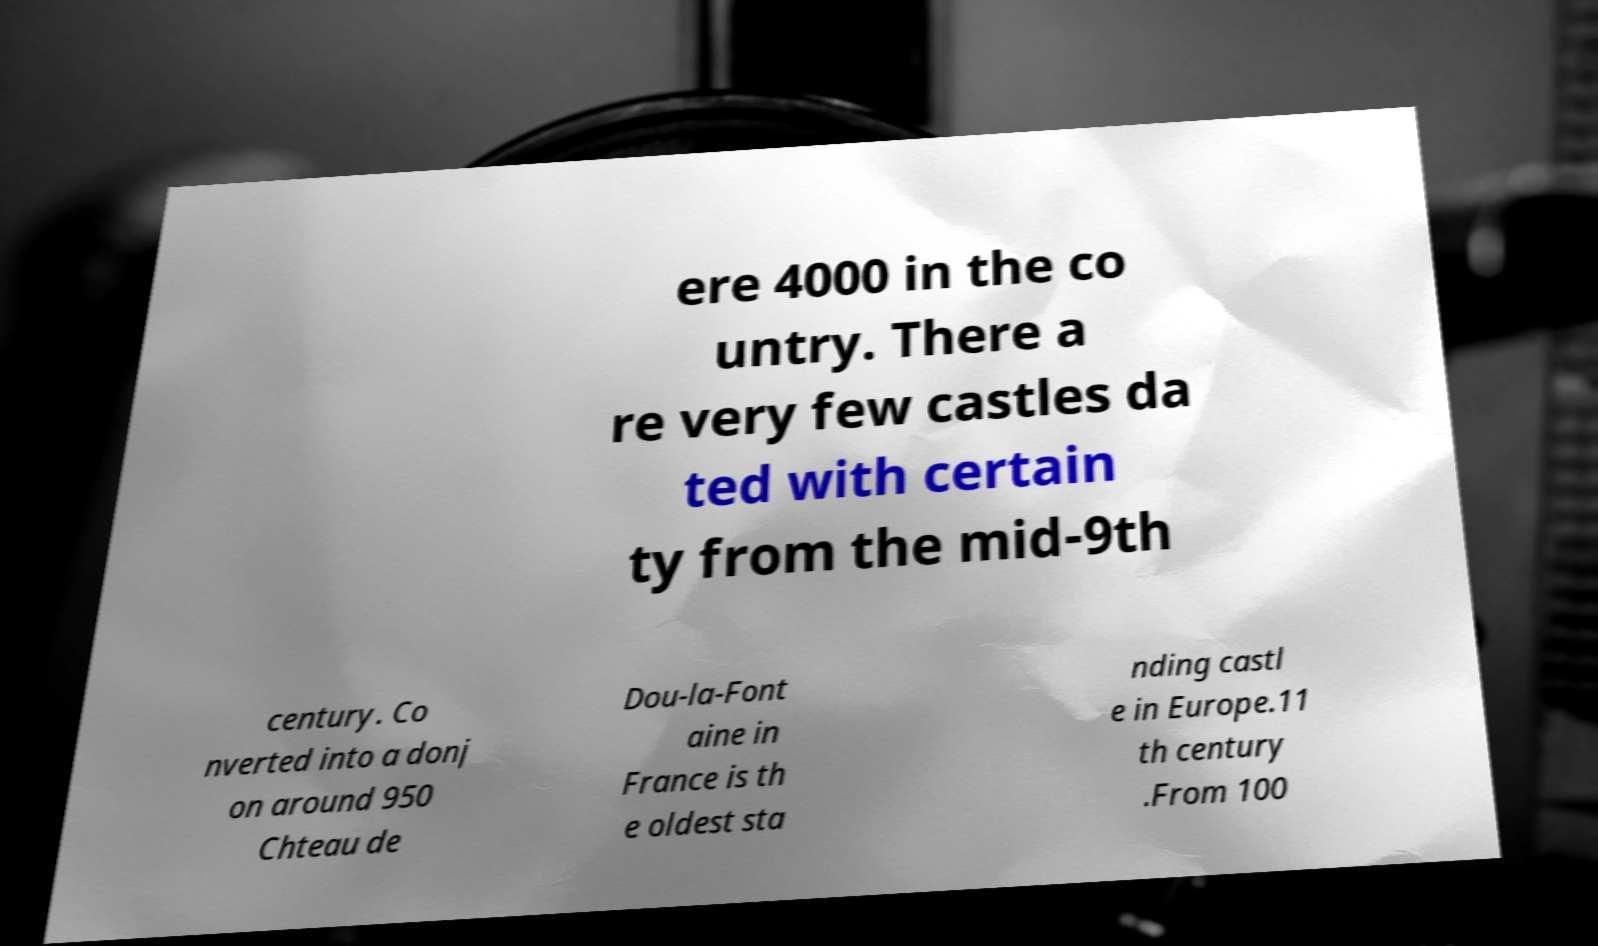Could you assist in decoding the text presented in this image and type it out clearly? ere 4000 in the co untry. There a re very few castles da ted with certain ty from the mid-9th century. Co nverted into a donj on around 950 Chteau de Dou-la-Font aine in France is th e oldest sta nding castl e in Europe.11 th century .From 100 